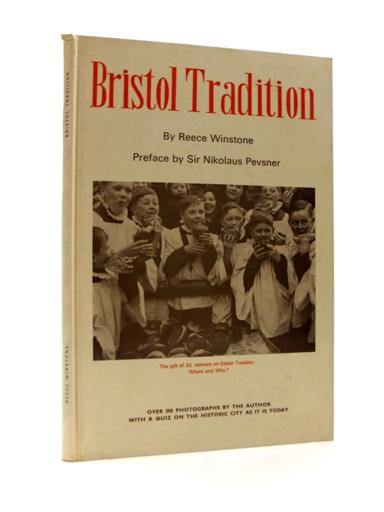What is the subject of the photograph on the book cover? The photograph on the cover of "Bristol Tradition" vividly captures a group of children, possibly choristers, in a church setting, embodying a moment of joyous expression. This image may symbolize the tradition and community spirit prevalent in Bristol. 